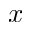<formula> <loc_0><loc_0><loc_500><loc_500>x</formula> 